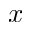<formula> <loc_0><loc_0><loc_500><loc_500>x</formula> 